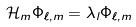<formula> <loc_0><loc_0><loc_500><loc_500>\mathcal { H } _ { m } \Phi _ { \ell , m } = \lambda _ { l } \Phi _ { \ell , m }</formula> 